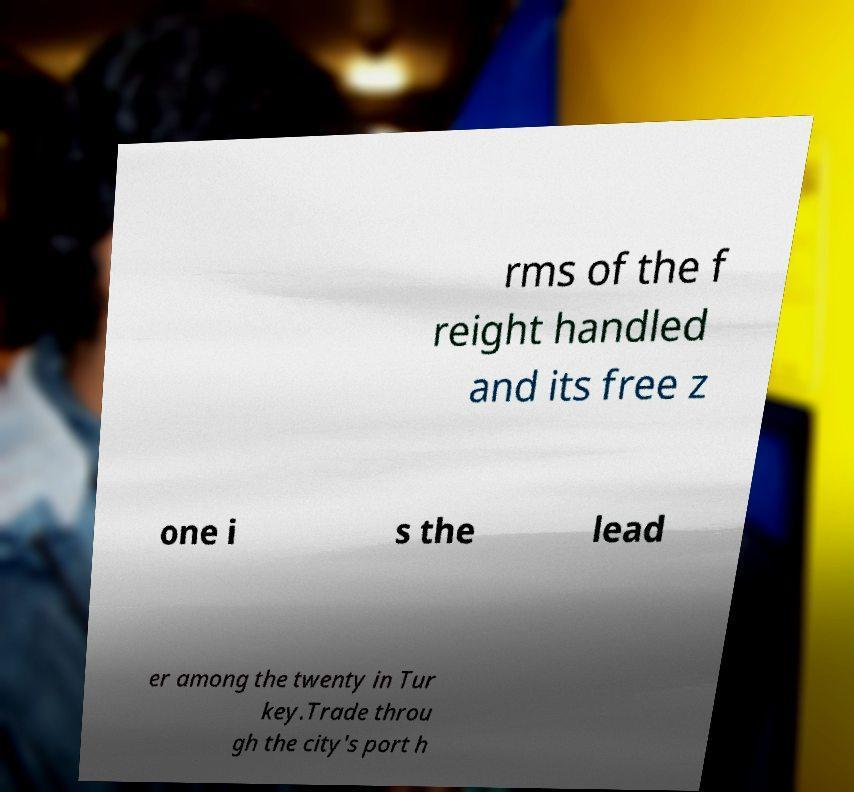What messages or text are displayed in this image? I need them in a readable, typed format. rms of the f reight handled and its free z one i s the lead er among the twenty in Tur key.Trade throu gh the city's port h 